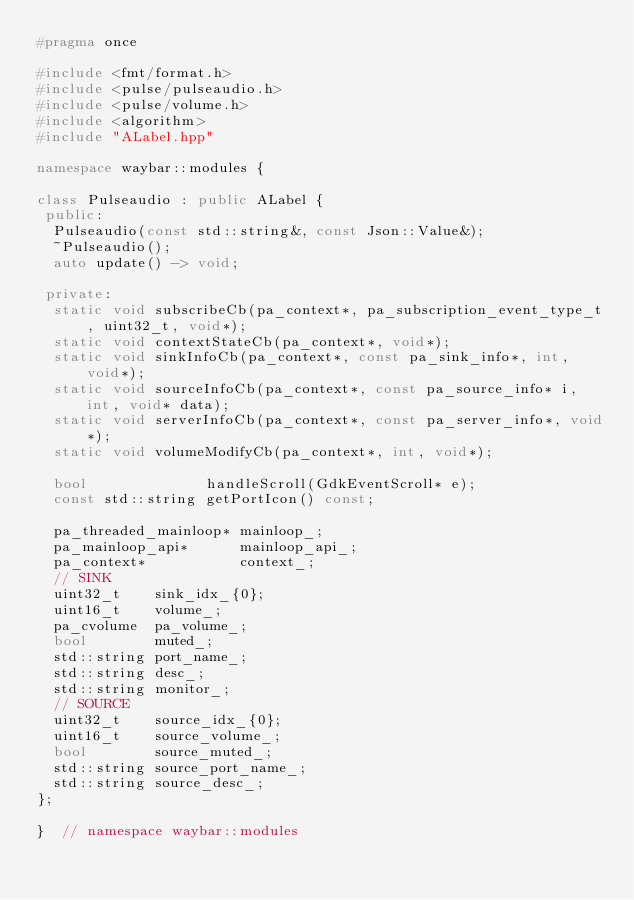Convert code to text. <code><loc_0><loc_0><loc_500><loc_500><_C++_>#pragma once

#include <fmt/format.h>
#include <pulse/pulseaudio.h>
#include <pulse/volume.h>
#include <algorithm>
#include "ALabel.hpp"

namespace waybar::modules {

class Pulseaudio : public ALabel {
 public:
  Pulseaudio(const std::string&, const Json::Value&);
  ~Pulseaudio();
  auto update() -> void;

 private:
  static void subscribeCb(pa_context*, pa_subscription_event_type_t, uint32_t, void*);
  static void contextStateCb(pa_context*, void*);
  static void sinkInfoCb(pa_context*, const pa_sink_info*, int, void*);
  static void sourceInfoCb(pa_context*, const pa_source_info* i, int, void* data);
  static void serverInfoCb(pa_context*, const pa_server_info*, void*);
  static void volumeModifyCb(pa_context*, int, void*);

  bool              handleScroll(GdkEventScroll* e);
  const std::string getPortIcon() const;

  pa_threaded_mainloop* mainloop_;
  pa_mainloop_api*      mainloop_api_;
  pa_context*           context_;
  // SINK
  uint32_t    sink_idx_{0};
  uint16_t    volume_;
  pa_cvolume  pa_volume_;
  bool        muted_;
  std::string port_name_;
  std::string desc_;
  std::string monitor_;
  // SOURCE
  uint32_t    source_idx_{0};
  uint16_t    source_volume_;
  bool        source_muted_;
  std::string source_port_name_;
  std::string source_desc_;
};

}  // namespace waybar::modules
</code> 